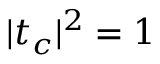Convert formula to latex. <formula><loc_0><loc_0><loc_500><loc_500>| t _ { c } | ^ { 2 } = 1</formula> 